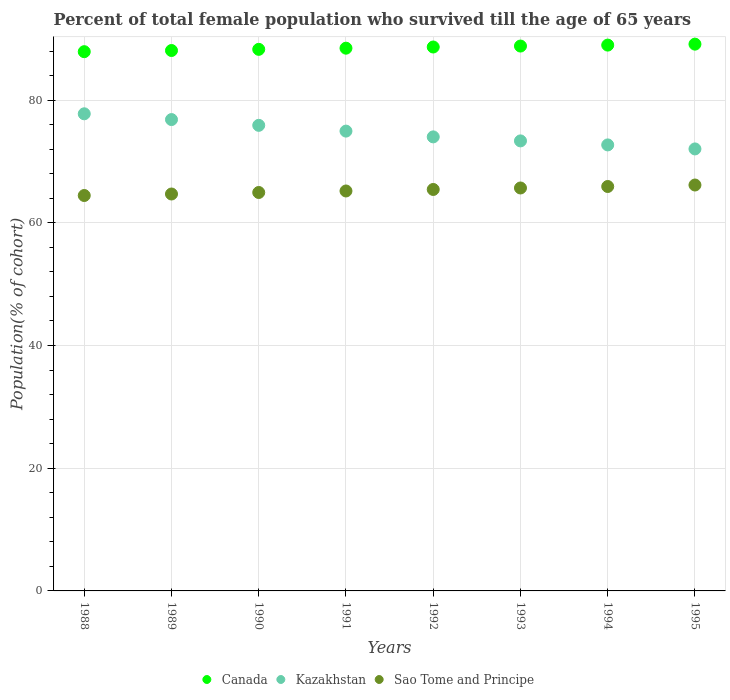How many different coloured dotlines are there?
Provide a short and direct response. 3. What is the percentage of total female population who survived till the age of 65 years in Kazakhstan in 1988?
Keep it short and to the point. 77.77. Across all years, what is the maximum percentage of total female population who survived till the age of 65 years in Sao Tome and Principe?
Offer a terse response. 66.17. Across all years, what is the minimum percentage of total female population who survived till the age of 65 years in Kazakhstan?
Ensure brevity in your answer.  72.05. In which year was the percentage of total female population who survived till the age of 65 years in Kazakhstan minimum?
Provide a short and direct response. 1995. What is the total percentage of total female population who survived till the age of 65 years in Sao Tome and Principe in the graph?
Make the answer very short. 522.51. What is the difference between the percentage of total female population who survived till the age of 65 years in Sao Tome and Principe in 1993 and that in 1995?
Ensure brevity in your answer.  -0.48. What is the difference between the percentage of total female population who survived till the age of 65 years in Canada in 1993 and the percentage of total female population who survived till the age of 65 years in Kazakhstan in 1991?
Make the answer very short. 13.86. What is the average percentage of total female population who survived till the age of 65 years in Canada per year?
Give a very brief answer. 88.54. In the year 1991, what is the difference between the percentage of total female population who survived till the age of 65 years in Kazakhstan and percentage of total female population who survived till the age of 65 years in Sao Tome and Principe?
Your response must be concise. 9.76. What is the ratio of the percentage of total female population who survived till the age of 65 years in Canada in 1992 to that in 1993?
Your response must be concise. 1. What is the difference between the highest and the second highest percentage of total female population who survived till the age of 65 years in Canada?
Give a very brief answer. 0.16. What is the difference between the highest and the lowest percentage of total female population who survived till the age of 65 years in Kazakhstan?
Ensure brevity in your answer.  5.73. Is it the case that in every year, the sum of the percentage of total female population who survived till the age of 65 years in Canada and percentage of total female population who survived till the age of 65 years in Sao Tome and Principe  is greater than the percentage of total female population who survived till the age of 65 years in Kazakhstan?
Provide a succinct answer. Yes. Does the percentage of total female population who survived till the age of 65 years in Sao Tome and Principe monotonically increase over the years?
Keep it short and to the point. Yes. How many dotlines are there?
Provide a short and direct response. 3. Are the values on the major ticks of Y-axis written in scientific E-notation?
Provide a short and direct response. No. Does the graph contain any zero values?
Offer a very short reply. No. How are the legend labels stacked?
Provide a succinct answer. Horizontal. What is the title of the graph?
Your answer should be very brief. Percent of total female population who survived till the age of 65 years. Does "Nigeria" appear as one of the legend labels in the graph?
Give a very brief answer. No. What is the label or title of the X-axis?
Offer a terse response. Years. What is the label or title of the Y-axis?
Provide a short and direct response. Population(% of cohort). What is the Population(% of cohort) of Canada in 1988?
Ensure brevity in your answer.  87.9. What is the Population(% of cohort) of Kazakhstan in 1988?
Your answer should be compact. 77.77. What is the Population(% of cohort) of Sao Tome and Principe in 1988?
Your answer should be compact. 64.45. What is the Population(% of cohort) in Canada in 1989?
Provide a short and direct response. 88.09. What is the Population(% of cohort) in Kazakhstan in 1989?
Your response must be concise. 76.83. What is the Population(% of cohort) of Sao Tome and Principe in 1989?
Keep it short and to the point. 64.7. What is the Population(% of cohort) of Canada in 1990?
Your answer should be very brief. 88.28. What is the Population(% of cohort) in Kazakhstan in 1990?
Offer a very short reply. 75.89. What is the Population(% of cohort) of Sao Tome and Principe in 1990?
Offer a very short reply. 64.95. What is the Population(% of cohort) in Canada in 1991?
Your answer should be compact. 88.47. What is the Population(% of cohort) of Kazakhstan in 1991?
Your answer should be compact. 74.95. What is the Population(% of cohort) of Sao Tome and Principe in 1991?
Offer a very short reply. 65.19. What is the Population(% of cohort) of Canada in 1992?
Make the answer very short. 88.66. What is the Population(% of cohort) in Kazakhstan in 1992?
Offer a very short reply. 74.01. What is the Population(% of cohort) in Sao Tome and Principe in 1992?
Your response must be concise. 65.44. What is the Population(% of cohort) in Canada in 1993?
Ensure brevity in your answer.  88.82. What is the Population(% of cohort) of Kazakhstan in 1993?
Ensure brevity in your answer.  73.36. What is the Population(% of cohort) of Sao Tome and Principe in 1993?
Provide a short and direct response. 65.68. What is the Population(% of cohort) of Canada in 1994?
Your answer should be very brief. 88.97. What is the Population(% of cohort) in Kazakhstan in 1994?
Provide a succinct answer. 72.7. What is the Population(% of cohort) of Sao Tome and Principe in 1994?
Ensure brevity in your answer.  65.92. What is the Population(% of cohort) of Canada in 1995?
Make the answer very short. 89.13. What is the Population(% of cohort) of Kazakhstan in 1995?
Provide a succinct answer. 72.05. What is the Population(% of cohort) in Sao Tome and Principe in 1995?
Ensure brevity in your answer.  66.17. Across all years, what is the maximum Population(% of cohort) of Canada?
Your response must be concise. 89.13. Across all years, what is the maximum Population(% of cohort) in Kazakhstan?
Offer a very short reply. 77.77. Across all years, what is the maximum Population(% of cohort) of Sao Tome and Principe?
Your answer should be very brief. 66.17. Across all years, what is the minimum Population(% of cohort) of Canada?
Offer a terse response. 87.9. Across all years, what is the minimum Population(% of cohort) of Kazakhstan?
Offer a terse response. 72.05. Across all years, what is the minimum Population(% of cohort) in Sao Tome and Principe?
Provide a succinct answer. 64.45. What is the total Population(% of cohort) in Canada in the graph?
Keep it short and to the point. 708.32. What is the total Population(% of cohort) of Kazakhstan in the graph?
Provide a short and direct response. 597.57. What is the total Population(% of cohort) in Sao Tome and Principe in the graph?
Give a very brief answer. 522.51. What is the difference between the Population(% of cohort) in Canada in 1988 and that in 1989?
Provide a short and direct response. -0.19. What is the difference between the Population(% of cohort) in Kazakhstan in 1988 and that in 1989?
Your answer should be compact. 0.94. What is the difference between the Population(% of cohort) of Sao Tome and Principe in 1988 and that in 1989?
Offer a terse response. -0.25. What is the difference between the Population(% of cohort) of Canada in 1988 and that in 1990?
Ensure brevity in your answer.  -0.38. What is the difference between the Population(% of cohort) of Kazakhstan in 1988 and that in 1990?
Provide a short and direct response. 1.88. What is the difference between the Population(% of cohort) of Sao Tome and Principe in 1988 and that in 1990?
Ensure brevity in your answer.  -0.49. What is the difference between the Population(% of cohort) in Canada in 1988 and that in 1991?
Offer a terse response. -0.57. What is the difference between the Population(% of cohort) in Kazakhstan in 1988 and that in 1991?
Give a very brief answer. 2.82. What is the difference between the Population(% of cohort) of Sao Tome and Principe in 1988 and that in 1991?
Offer a very short reply. -0.74. What is the difference between the Population(% of cohort) in Canada in 1988 and that in 1992?
Ensure brevity in your answer.  -0.76. What is the difference between the Population(% of cohort) of Kazakhstan in 1988 and that in 1992?
Give a very brief answer. 3.76. What is the difference between the Population(% of cohort) in Sao Tome and Principe in 1988 and that in 1992?
Offer a terse response. -0.99. What is the difference between the Population(% of cohort) of Canada in 1988 and that in 1993?
Ensure brevity in your answer.  -0.92. What is the difference between the Population(% of cohort) in Kazakhstan in 1988 and that in 1993?
Provide a succinct answer. 4.42. What is the difference between the Population(% of cohort) in Sao Tome and Principe in 1988 and that in 1993?
Your answer should be compact. -1.23. What is the difference between the Population(% of cohort) of Canada in 1988 and that in 1994?
Offer a terse response. -1.07. What is the difference between the Population(% of cohort) of Kazakhstan in 1988 and that in 1994?
Offer a terse response. 5.07. What is the difference between the Population(% of cohort) of Sao Tome and Principe in 1988 and that in 1994?
Give a very brief answer. -1.47. What is the difference between the Population(% of cohort) in Canada in 1988 and that in 1995?
Offer a very short reply. -1.23. What is the difference between the Population(% of cohort) in Kazakhstan in 1988 and that in 1995?
Ensure brevity in your answer.  5.73. What is the difference between the Population(% of cohort) in Sao Tome and Principe in 1988 and that in 1995?
Provide a succinct answer. -1.71. What is the difference between the Population(% of cohort) of Canada in 1989 and that in 1990?
Provide a short and direct response. -0.19. What is the difference between the Population(% of cohort) in Kazakhstan in 1989 and that in 1990?
Offer a very short reply. 0.94. What is the difference between the Population(% of cohort) in Sao Tome and Principe in 1989 and that in 1990?
Provide a succinct answer. -0.25. What is the difference between the Population(% of cohort) in Canada in 1989 and that in 1991?
Offer a very short reply. -0.38. What is the difference between the Population(% of cohort) of Kazakhstan in 1989 and that in 1991?
Give a very brief answer. 1.88. What is the difference between the Population(% of cohort) in Sao Tome and Principe in 1989 and that in 1991?
Provide a succinct answer. -0.49. What is the difference between the Population(% of cohort) in Canada in 1989 and that in 1992?
Give a very brief answer. -0.57. What is the difference between the Population(% of cohort) of Kazakhstan in 1989 and that in 1992?
Provide a short and direct response. 2.82. What is the difference between the Population(% of cohort) in Sao Tome and Principe in 1989 and that in 1992?
Provide a succinct answer. -0.74. What is the difference between the Population(% of cohort) of Canada in 1989 and that in 1993?
Your answer should be compact. -0.73. What is the difference between the Population(% of cohort) in Kazakhstan in 1989 and that in 1993?
Provide a short and direct response. 3.48. What is the difference between the Population(% of cohort) of Sao Tome and Principe in 1989 and that in 1993?
Your answer should be compact. -0.98. What is the difference between the Population(% of cohort) in Canada in 1989 and that in 1994?
Make the answer very short. -0.88. What is the difference between the Population(% of cohort) of Kazakhstan in 1989 and that in 1994?
Keep it short and to the point. 4.13. What is the difference between the Population(% of cohort) of Sao Tome and Principe in 1989 and that in 1994?
Offer a terse response. -1.22. What is the difference between the Population(% of cohort) in Canada in 1989 and that in 1995?
Provide a short and direct response. -1.04. What is the difference between the Population(% of cohort) of Kazakhstan in 1989 and that in 1995?
Give a very brief answer. 4.79. What is the difference between the Population(% of cohort) in Sao Tome and Principe in 1989 and that in 1995?
Provide a short and direct response. -1.46. What is the difference between the Population(% of cohort) in Canada in 1990 and that in 1991?
Offer a very short reply. -0.19. What is the difference between the Population(% of cohort) in Kazakhstan in 1990 and that in 1991?
Your answer should be very brief. 0.94. What is the difference between the Population(% of cohort) in Sao Tome and Principe in 1990 and that in 1991?
Provide a short and direct response. -0.25. What is the difference between the Population(% of cohort) in Canada in 1990 and that in 1992?
Offer a very short reply. -0.38. What is the difference between the Population(% of cohort) of Kazakhstan in 1990 and that in 1992?
Offer a very short reply. 1.88. What is the difference between the Population(% of cohort) of Sao Tome and Principe in 1990 and that in 1992?
Your answer should be very brief. -0.49. What is the difference between the Population(% of cohort) in Canada in 1990 and that in 1993?
Your answer should be very brief. -0.54. What is the difference between the Population(% of cohort) in Kazakhstan in 1990 and that in 1993?
Keep it short and to the point. 2.54. What is the difference between the Population(% of cohort) of Sao Tome and Principe in 1990 and that in 1993?
Ensure brevity in your answer.  -0.73. What is the difference between the Population(% of cohort) in Canada in 1990 and that in 1994?
Keep it short and to the point. -0.69. What is the difference between the Population(% of cohort) in Kazakhstan in 1990 and that in 1994?
Ensure brevity in your answer.  3.19. What is the difference between the Population(% of cohort) in Sao Tome and Principe in 1990 and that in 1994?
Keep it short and to the point. -0.98. What is the difference between the Population(% of cohort) of Canada in 1990 and that in 1995?
Offer a terse response. -0.85. What is the difference between the Population(% of cohort) in Kazakhstan in 1990 and that in 1995?
Ensure brevity in your answer.  3.84. What is the difference between the Population(% of cohort) of Sao Tome and Principe in 1990 and that in 1995?
Offer a very short reply. -1.22. What is the difference between the Population(% of cohort) of Canada in 1991 and that in 1992?
Offer a terse response. -0.19. What is the difference between the Population(% of cohort) of Kazakhstan in 1991 and that in 1992?
Make the answer very short. 0.94. What is the difference between the Population(% of cohort) in Sao Tome and Principe in 1991 and that in 1992?
Your response must be concise. -0.25. What is the difference between the Population(% of cohort) in Canada in 1991 and that in 1993?
Your answer should be very brief. -0.35. What is the difference between the Population(% of cohort) of Kazakhstan in 1991 and that in 1993?
Provide a short and direct response. 1.6. What is the difference between the Population(% of cohort) of Sao Tome and Principe in 1991 and that in 1993?
Keep it short and to the point. -0.49. What is the difference between the Population(% of cohort) in Canada in 1991 and that in 1994?
Provide a short and direct response. -0.5. What is the difference between the Population(% of cohort) of Kazakhstan in 1991 and that in 1994?
Keep it short and to the point. 2.25. What is the difference between the Population(% of cohort) of Sao Tome and Principe in 1991 and that in 1994?
Keep it short and to the point. -0.73. What is the difference between the Population(% of cohort) of Canada in 1991 and that in 1995?
Your answer should be very brief. -0.66. What is the difference between the Population(% of cohort) in Kazakhstan in 1991 and that in 1995?
Keep it short and to the point. 2.9. What is the difference between the Population(% of cohort) of Sao Tome and Principe in 1991 and that in 1995?
Make the answer very short. -0.97. What is the difference between the Population(% of cohort) in Canada in 1992 and that in 1993?
Your response must be concise. -0.16. What is the difference between the Population(% of cohort) of Kazakhstan in 1992 and that in 1993?
Make the answer very short. 0.65. What is the difference between the Population(% of cohort) of Sao Tome and Principe in 1992 and that in 1993?
Offer a very short reply. -0.24. What is the difference between the Population(% of cohort) in Canada in 1992 and that in 1994?
Provide a succinct answer. -0.31. What is the difference between the Population(% of cohort) of Kazakhstan in 1992 and that in 1994?
Ensure brevity in your answer.  1.31. What is the difference between the Population(% of cohort) in Sao Tome and Principe in 1992 and that in 1994?
Give a very brief answer. -0.48. What is the difference between the Population(% of cohort) in Canada in 1992 and that in 1995?
Keep it short and to the point. -0.47. What is the difference between the Population(% of cohort) of Kazakhstan in 1992 and that in 1995?
Your answer should be very brief. 1.96. What is the difference between the Population(% of cohort) of Sao Tome and Principe in 1992 and that in 1995?
Your answer should be very brief. -0.73. What is the difference between the Population(% of cohort) of Canada in 1993 and that in 1994?
Offer a terse response. -0.16. What is the difference between the Population(% of cohort) of Kazakhstan in 1993 and that in 1994?
Make the answer very short. 0.65. What is the difference between the Population(% of cohort) of Sao Tome and Principe in 1993 and that in 1994?
Offer a very short reply. -0.24. What is the difference between the Population(% of cohort) in Canada in 1993 and that in 1995?
Your answer should be compact. -0.31. What is the difference between the Population(% of cohort) of Kazakhstan in 1993 and that in 1995?
Offer a terse response. 1.31. What is the difference between the Population(% of cohort) of Sao Tome and Principe in 1993 and that in 1995?
Your response must be concise. -0.48. What is the difference between the Population(% of cohort) in Canada in 1994 and that in 1995?
Ensure brevity in your answer.  -0.16. What is the difference between the Population(% of cohort) of Kazakhstan in 1994 and that in 1995?
Your answer should be compact. 0.65. What is the difference between the Population(% of cohort) of Sao Tome and Principe in 1994 and that in 1995?
Your response must be concise. -0.24. What is the difference between the Population(% of cohort) of Canada in 1988 and the Population(% of cohort) of Kazakhstan in 1989?
Ensure brevity in your answer.  11.07. What is the difference between the Population(% of cohort) of Canada in 1988 and the Population(% of cohort) of Sao Tome and Principe in 1989?
Your answer should be very brief. 23.2. What is the difference between the Population(% of cohort) of Kazakhstan in 1988 and the Population(% of cohort) of Sao Tome and Principe in 1989?
Offer a terse response. 13.07. What is the difference between the Population(% of cohort) of Canada in 1988 and the Population(% of cohort) of Kazakhstan in 1990?
Keep it short and to the point. 12.01. What is the difference between the Population(% of cohort) of Canada in 1988 and the Population(% of cohort) of Sao Tome and Principe in 1990?
Give a very brief answer. 22.95. What is the difference between the Population(% of cohort) of Kazakhstan in 1988 and the Population(% of cohort) of Sao Tome and Principe in 1990?
Offer a very short reply. 12.83. What is the difference between the Population(% of cohort) of Canada in 1988 and the Population(% of cohort) of Kazakhstan in 1991?
Ensure brevity in your answer.  12.95. What is the difference between the Population(% of cohort) in Canada in 1988 and the Population(% of cohort) in Sao Tome and Principe in 1991?
Ensure brevity in your answer.  22.71. What is the difference between the Population(% of cohort) in Kazakhstan in 1988 and the Population(% of cohort) in Sao Tome and Principe in 1991?
Provide a short and direct response. 12.58. What is the difference between the Population(% of cohort) of Canada in 1988 and the Population(% of cohort) of Kazakhstan in 1992?
Ensure brevity in your answer.  13.89. What is the difference between the Population(% of cohort) of Canada in 1988 and the Population(% of cohort) of Sao Tome and Principe in 1992?
Offer a very short reply. 22.46. What is the difference between the Population(% of cohort) in Kazakhstan in 1988 and the Population(% of cohort) in Sao Tome and Principe in 1992?
Offer a terse response. 12.33. What is the difference between the Population(% of cohort) in Canada in 1988 and the Population(% of cohort) in Kazakhstan in 1993?
Make the answer very short. 14.54. What is the difference between the Population(% of cohort) of Canada in 1988 and the Population(% of cohort) of Sao Tome and Principe in 1993?
Provide a short and direct response. 22.22. What is the difference between the Population(% of cohort) in Kazakhstan in 1988 and the Population(% of cohort) in Sao Tome and Principe in 1993?
Provide a succinct answer. 12.09. What is the difference between the Population(% of cohort) of Canada in 1988 and the Population(% of cohort) of Kazakhstan in 1994?
Your answer should be very brief. 15.2. What is the difference between the Population(% of cohort) in Canada in 1988 and the Population(% of cohort) in Sao Tome and Principe in 1994?
Keep it short and to the point. 21.98. What is the difference between the Population(% of cohort) in Kazakhstan in 1988 and the Population(% of cohort) in Sao Tome and Principe in 1994?
Ensure brevity in your answer.  11.85. What is the difference between the Population(% of cohort) of Canada in 1988 and the Population(% of cohort) of Kazakhstan in 1995?
Ensure brevity in your answer.  15.85. What is the difference between the Population(% of cohort) in Canada in 1988 and the Population(% of cohort) in Sao Tome and Principe in 1995?
Provide a succinct answer. 21.73. What is the difference between the Population(% of cohort) of Kazakhstan in 1988 and the Population(% of cohort) of Sao Tome and Principe in 1995?
Provide a short and direct response. 11.61. What is the difference between the Population(% of cohort) of Canada in 1989 and the Population(% of cohort) of Kazakhstan in 1990?
Keep it short and to the point. 12.2. What is the difference between the Population(% of cohort) of Canada in 1989 and the Population(% of cohort) of Sao Tome and Principe in 1990?
Make the answer very short. 23.14. What is the difference between the Population(% of cohort) of Kazakhstan in 1989 and the Population(% of cohort) of Sao Tome and Principe in 1990?
Ensure brevity in your answer.  11.89. What is the difference between the Population(% of cohort) in Canada in 1989 and the Population(% of cohort) in Kazakhstan in 1991?
Ensure brevity in your answer.  13.14. What is the difference between the Population(% of cohort) in Canada in 1989 and the Population(% of cohort) in Sao Tome and Principe in 1991?
Offer a very short reply. 22.9. What is the difference between the Population(% of cohort) in Kazakhstan in 1989 and the Population(% of cohort) in Sao Tome and Principe in 1991?
Your answer should be compact. 11.64. What is the difference between the Population(% of cohort) of Canada in 1989 and the Population(% of cohort) of Kazakhstan in 1992?
Provide a succinct answer. 14.08. What is the difference between the Population(% of cohort) of Canada in 1989 and the Population(% of cohort) of Sao Tome and Principe in 1992?
Keep it short and to the point. 22.65. What is the difference between the Population(% of cohort) in Kazakhstan in 1989 and the Population(% of cohort) in Sao Tome and Principe in 1992?
Your answer should be very brief. 11.39. What is the difference between the Population(% of cohort) in Canada in 1989 and the Population(% of cohort) in Kazakhstan in 1993?
Provide a short and direct response. 14.73. What is the difference between the Population(% of cohort) in Canada in 1989 and the Population(% of cohort) in Sao Tome and Principe in 1993?
Keep it short and to the point. 22.41. What is the difference between the Population(% of cohort) of Kazakhstan in 1989 and the Population(% of cohort) of Sao Tome and Principe in 1993?
Offer a very short reply. 11.15. What is the difference between the Population(% of cohort) of Canada in 1989 and the Population(% of cohort) of Kazakhstan in 1994?
Your answer should be compact. 15.39. What is the difference between the Population(% of cohort) in Canada in 1989 and the Population(% of cohort) in Sao Tome and Principe in 1994?
Offer a very short reply. 22.17. What is the difference between the Population(% of cohort) in Kazakhstan in 1989 and the Population(% of cohort) in Sao Tome and Principe in 1994?
Offer a very short reply. 10.91. What is the difference between the Population(% of cohort) in Canada in 1989 and the Population(% of cohort) in Kazakhstan in 1995?
Offer a terse response. 16.04. What is the difference between the Population(% of cohort) in Canada in 1989 and the Population(% of cohort) in Sao Tome and Principe in 1995?
Provide a short and direct response. 21.92. What is the difference between the Population(% of cohort) in Kazakhstan in 1989 and the Population(% of cohort) in Sao Tome and Principe in 1995?
Your answer should be compact. 10.67. What is the difference between the Population(% of cohort) in Canada in 1990 and the Population(% of cohort) in Kazakhstan in 1991?
Offer a very short reply. 13.33. What is the difference between the Population(% of cohort) of Canada in 1990 and the Population(% of cohort) of Sao Tome and Principe in 1991?
Keep it short and to the point. 23.09. What is the difference between the Population(% of cohort) of Kazakhstan in 1990 and the Population(% of cohort) of Sao Tome and Principe in 1991?
Your answer should be compact. 10.7. What is the difference between the Population(% of cohort) in Canada in 1990 and the Population(% of cohort) in Kazakhstan in 1992?
Provide a succinct answer. 14.27. What is the difference between the Population(% of cohort) in Canada in 1990 and the Population(% of cohort) in Sao Tome and Principe in 1992?
Keep it short and to the point. 22.84. What is the difference between the Population(% of cohort) in Kazakhstan in 1990 and the Population(% of cohort) in Sao Tome and Principe in 1992?
Keep it short and to the point. 10.45. What is the difference between the Population(% of cohort) of Canada in 1990 and the Population(% of cohort) of Kazakhstan in 1993?
Make the answer very short. 14.92. What is the difference between the Population(% of cohort) in Canada in 1990 and the Population(% of cohort) in Sao Tome and Principe in 1993?
Provide a succinct answer. 22.6. What is the difference between the Population(% of cohort) in Kazakhstan in 1990 and the Population(% of cohort) in Sao Tome and Principe in 1993?
Offer a terse response. 10.21. What is the difference between the Population(% of cohort) of Canada in 1990 and the Population(% of cohort) of Kazakhstan in 1994?
Provide a short and direct response. 15.58. What is the difference between the Population(% of cohort) of Canada in 1990 and the Population(% of cohort) of Sao Tome and Principe in 1994?
Provide a succinct answer. 22.36. What is the difference between the Population(% of cohort) of Kazakhstan in 1990 and the Population(% of cohort) of Sao Tome and Principe in 1994?
Give a very brief answer. 9.97. What is the difference between the Population(% of cohort) in Canada in 1990 and the Population(% of cohort) in Kazakhstan in 1995?
Give a very brief answer. 16.23. What is the difference between the Population(% of cohort) in Canada in 1990 and the Population(% of cohort) in Sao Tome and Principe in 1995?
Give a very brief answer. 22.11. What is the difference between the Population(% of cohort) in Kazakhstan in 1990 and the Population(% of cohort) in Sao Tome and Principe in 1995?
Provide a succinct answer. 9.73. What is the difference between the Population(% of cohort) of Canada in 1991 and the Population(% of cohort) of Kazakhstan in 1992?
Offer a terse response. 14.46. What is the difference between the Population(% of cohort) in Canada in 1991 and the Population(% of cohort) in Sao Tome and Principe in 1992?
Your answer should be compact. 23.03. What is the difference between the Population(% of cohort) in Kazakhstan in 1991 and the Population(% of cohort) in Sao Tome and Principe in 1992?
Give a very brief answer. 9.51. What is the difference between the Population(% of cohort) of Canada in 1991 and the Population(% of cohort) of Kazakhstan in 1993?
Provide a short and direct response. 15.11. What is the difference between the Population(% of cohort) of Canada in 1991 and the Population(% of cohort) of Sao Tome and Principe in 1993?
Offer a terse response. 22.79. What is the difference between the Population(% of cohort) in Kazakhstan in 1991 and the Population(% of cohort) in Sao Tome and Principe in 1993?
Your answer should be very brief. 9.27. What is the difference between the Population(% of cohort) of Canada in 1991 and the Population(% of cohort) of Kazakhstan in 1994?
Provide a short and direct response. 15.77. What is the difference between the Population(% of cohort) in Canada in 1991 and the Population(% of cohort) in Sao Tome and Principe in 1994?
Provide a short and direct response. 22.55. What is the difference between the Population(% of cohort) of Kazakhstan in 1991 and the Population(% of cohort) of Sao Tome and Principe in 1994?
Ensure brevity in your answer.  9.03. What is the difference between the Population(% of cohort) of Canada in 1991 and the Population(% of cohort) of Kazakhstan in 1995?
Offer a very short reply. 16.42. What is the difference between the Population(% of cohort) in Canada in 1991 and the Population(% of cohort) in Sao Tome and Principe in 1995?
Make the answer very short. 22.31. What is the difference between the Population(% of cohort) in Kazakhstan in 1991 and the Population(% of cohort) in Sao Tome and Principe in 1995?
Provide a short and direct response. 8.79. What is the difference between the Population(% of cohort) of Canada in 1992 and the Population(% of cohort) of Kazakhstan in 1993?
Your response must be concise. 15.3. What is the difference between the Population(% of cohort) of Canada in 1992 and the Population(% of cohort) of Sao Tome and Principe in 1993?
Provide a succinct answer. 22.98. What is the difference between the Population(% of cohort) in Kazakhstan in 1992 and the Population(% of cohort) in Sao Tome and Principe in 1993?
Offer a terse response. 8.33. What is the difference between the Population(% of cohort) of Canada in 1992 and the Population(% of cohort) of Kazakhstan in 1994?
Your response must be concise. 15.96. What is the difference between the Population(% of cohort) of Canada in 1992 and the Population(% of cohort) of Sao Tome and Principe in 1994?
Give a very brief answer. 22.74. What is the difference between the Population(% of cohort) in Kazakhstan in 1992 and the Population(% of cohort) in Sao Tome and Principe in 1994?
Make the answer very short. 8.09. What is the difference between the Population(% of cohort) in Canada in 1992 and the Population(% of cohort) in Kazakhstan in 1995?
Your response must be concise. 16.61. What is the difference between the Population(% of cohort) in Canada in 1992 and the Population(% of cohort) in Sao Tome and Principe in 1995?
Your answer should be compact. 22.5. What is the difference between the Population(% of cohort) in Kazakhstan in 1992 and the Population(% of cohort) in Sao Tome and Principe in 1995?
Provide a short and direct response. 7.85. What is the difference between the Population(% of cohort) of Canada in 1993 and the Population(% of cohort) of Kazakhstan in 1994?
Give a very brief answer. 16.11. What is the difference between the Population(% of cohort) in Canada in 1993 and the Population(% of cohort) in Sao Tome and Principe in 1994?
Make the answer very short. 22.89. What is the difference between the Population(% of cohort) in Kazakhstan in 1993 and the Population(% of cohort) in Sao Tome and Principe in 1994?
Your answer should be compact. 7.43. What is the difference between the Population(% of cohort) of Canada in 1993 and the Population(% of cohort) of Kazakhstan in 1995?
Keep it short and to the point. 16.77. What is the difference between the Population(% of cohort) of Canada in 1993 and the Population(% of cohort) of Sao Tome and Principe in 1995?
Offer a terse response. 22.65. What is the difference between the Population(% of cohort) in Kazakhstan in 1993 and the Population(% of cohort) in Sao Tome and Principe in 1995?
Your response must be concise. 7.19. What is the difference between the Population(% of cohort) in Canada in 1994 and the Population(% of cohort) in Kazakhstan in 1995?
Ensure brevity in your answer.  16.92. What is the difference between the Population(% of cohort) in Canada in 1994 and the Population(% of cohort) in Sao Tome and Principe in 1995?
Your answer should be compact. 22.81. What is the difference between the Population(% of cohort) of Kazakhstan in 1994 and the Population(% of cohort) of Sao Tome and Principe in 1995?
Ensure brevity in your answer.  6.54. What is the average Population(% of cohort) of Canada per year?
Keep it short and to the point. 88.54. What is the average Population(% of cohort) in Kazakhstan per year?
Your answer should be compact. 74.7. What is the average Population(% of cohort) of Sao Tome and Principe per year?
Make the answer very short. 65.31. In the year 1988, what is the difference between the Population(% of cohort) of Canada and Population(% of cohort) of Kazakhstan?
Give a very brief answer. 10.13. In the year 1988, what is the difference between the Population(% of cohort) of Canada and Population(% of cohort) of Sao Tome and Principe?
Your response must be concise. 23.45. In the year 1988, what is the difference between the Population(% of cohort) in Kazakhstan and Population(% of cohort) in Sao Tome and Principe?
Make the answer very short. 13.32. In the year 1989, what is the difference between the Population(% of cohort) in Canada and Population(% of cohort) in Kazakhstan?
Offer a terse response. 11.26. In the year 1989, what is the difference between the Population(% of cohort) in Canada and Population(% of cohort) in Sao Tome and Principe?
Ensure brevity in your answer.  23.39. In the year 1989, what is the difference between the Population(% of cohort) of Kazakhstan and Population(% of cohort) of Sao Tome and Principe?
Provide a short and direct response. 12.13. In the year 1990, what is the difference between the Population(% of cohort) of Canada and Population(% of cohort) of Kazakhstan?
Your answer should be very brief. 12.39. In the year 1990, what is the difference between the Population(% of cohort) of Canada and Population(% of cohort) of Sao Tome and Principe?
Provide a succinct answer. 23.33. In the year 1990, what is the difference between the Population(% of cohort) in Kazakhstan and Population(% of cohort) in Sao Tome and Principe?
Your answer should be very brief. 10.95. In the year 1991, what is the difference between the Population(% of cohort) in Canada and Population(% of cohort) in Kazakhstan?
Your answer should be very brief. 13.52. In the year 1991, what is the difference between the Population(% of cohort) in Canada and Population(% of cohort) in Sao Tome and Principe?
Ensure brevity in your answer.  23.28. In the year 1991, what is the difference between the Population(% of cohort) of Kazakhstan and Population(% of cohort) of Sao Tome and Principe?
Make the answer very short. 9.76. In the year 1992, what is the difference between the Population(% of cohort) in Canada and Population(% of cohort) in Kazakhstan?
Offer a very short reply. 14.65. In the year 1992, what is the difference between the Population(% of cohort) of Canada and Population(% of cohort) of Sao Tome and Principe?
Your answer should be compact. 23.22. In the year 1992, what is the difference between the Population(% of cohort) in Kazakhstan and Population(% of cohort) in Sao Tome and Principe?
Your answer should be compact. 8.57. In the year 1993, what is the difference between the Population(% of cohort) of Canada and Population(% of cohort) of Kazakhstan?
Give a very brief answer. 15.46. In the year 1993, what is the difference between the Population(% of cohort) of Canada and Population(% of cohort) of Sao Tome and Principe?
Your answer should be very brief. 23.14. In the year 1993, what is the difference between the Population(% of cohort) of Kazakhstan and Population(% of cohort) of Sao Tome and Principe?
Keep it short and to the point. 7.68. In the year 1994, what is the difference between the Population(% of cohort) in Canada and Population(% of cohort) in Kazakhstan?
Provide a short and direct response. 16.27. In the year 1994, what is the difference between the Population(% of cohort) of Canada and Population(% of cohort) of Sao Tome and Principe?
Give a very brief answer. 23.05. In the year 1994, what is the difference between the Population(% of cohort) in Kazakhstan and Population(% of cohort) in Sao Tome and Principe?
Provide a succinct answer. 6.78. In the year 1995, what is the difference between the Population(% of cohort) in Canada and Population(% of cohort) in Kazakhstan?
Make the answer very short. 17.08. In the year 1995, what is the difference between the Population(% of cohort) of Canada and Population(% of cohort) of Sao Tome and Principe?
Offer a very short reply. 22.96. In the year 1995, what is the difference between the Population(% of cohort) in Kazakhstan and Population(% of cohort) in Sao Tome and Principe?
Your answer should be very brief. 5.88. What is the ratio of the Population(% of cohort) in Canada in 1988 to that in 1989?
Make the answer very short. 1. What is the ratio of the Population(% of cohort) in Kazakhstan in 1988 to that in 1989?
Give a very brief answer. 1.01. What is the ratio of the Population(% of cohort) of Sao Tome and Principe in 1988 to that in 1989?
Provide a succinct answer. 1. What is the ratio of the Population(% of cohort) of Kazakhstan in 1988 to that in 1990?
Provide a succinct answer. 1.02. What is the ratio of the Population(% of cohort) in Canada in 1988 to that in 1991?
Offer a terse response. 0.99. What is the ratio of the Population(% of cohort) in Kazakhstan in 1988 to that in 1991?
Give a very brief answer. 1.04. What is the ratio of the Population(% of cohort) in Sao Tome and Principe in 1988 to that in 1991?
Give a very brief answer. 0.99. What is the ratio of the Population(% of cohort) in Kazakhstan in 1988 to that in 1992?
Your response must be concise. 1.05. What is the ratio of the Population(% of cohort) in Sao Tome and Principe in 1988 to that in 1992?
Provide a short and direct response. 0.98. What is the ratio of the Population(% of cohort) in Kazakhstan in 1988 to that in 1993?
Provide a succinct answer. 1.06. What is the ratio of the Population(% of cohort) of Sao Tome and Principe in 1988 to that in 1993?
Make the answer very short. 0.98. What is the ratio of the Population(% of cohort) in Canada in 1988 to that in 1994?
Keep it short and to the point. 0.99. What is the ratio of the Population(% of cohort) in Kazakhstan in 1988 to that in 1994?
Your answer should be compact. 1.07. What is the ratio of the Population(% of cohort) in Sao Tome and Principe in 1988 to that in 1994?
Offer a very short reply. 0.98. What is the ratio of the Population(% of cohort) in Canada in 1988 to that in 1995?
Offer a terse response. 0.99. What is the ratio of the Population(% of cohort) in Kazakhstan in 1988 to that in 1995?
Provide a short and direct response. 1.08. What is the ratio of the Population(% of cohort) of Sao Tome and Principe in 1988 to that in 1995?
Give a very brief answer. 0.97. What is the ratio of the Population(% of cohort) in Canada in 1989 to that in 1990?
Ensure brevity in your answer.  1. What is the ratio of the Population(% of cohort) of Kazakhstan in 1989 to that in 1990?
Your answer should be very brief. 1.01. What is the ratio of the Population(% of cohort) of Sao Tome and Principe in 1989 to that in 1990?
Your answer should be compact. 1. What is the ratio of the Population(% of cohort) of Kazakhstan in 1989 to that in 1991?
Your response must be concise. 1.03. What is the ratio of the Population(% of cohort) of Canada in 1989 to that in 1992?
Your answer should be very brief. 0.99. What is the ratio of the Population(% of cohort) in Kazakhstan in 1989 to that in 1992?
Your answer should be compact. 1.04. What is the ratio of the Population(% of cohort) in Sao Tome and Principe in 1989 to that in 1992?
Provide a short and direct response. 0.99. What is the ratio of the Population(% of cohort) in Canada in 1989 to that in 1993?
Give a very brief answer. 0.99. What is the ratio of the Population(% of cohort) in Kazakhstan in 1989 to that in 1993?
Keep it short and to the point. 1.05. What is the ratio of the Population(% of cohort) of Sao Tome and Principe in 1989 to that in 1993?
Give a very brief answer. 0.99. What is the ratio of the Population(% of cohort) of Kazakhstan in 1989 to that in 1994?
Offer a terse response. 1.06. What is the ratio of the Population(% of cohort) in Sao Tome and Principe in 1989 to that in 1994?
Make the answer very short. 0.98. What is the ratio of the Population(% of cohort) of Canada in 1989 to that in 1995?
Ensure brevity in your answer.  0.99. What is the ratio of the Population(% of cohort) of Kazakhstan in 1989 to that in 1995?
Keep it short and to the point. 1.07. What is the ratio of the Population(% of cohort) in Sao Tome and Principe in 1989 to that in 1995?
Offer a very short reply. 0.98. What is the ratio of the Population(% of cohort) of Canada in 1990 to that in 1991?
Give a very brief answer. 1. What is the ratio of the Population(% of cohort) in Kazakhstan in 1990 to that in 1991?
Offer a very short reply. 1.01. What is the ratio of the Population(% of cohort) in Kazakhstan in 1990 to that in 1992?
Make the answer very short. 1.03. What is the ratio of the Population(% of cohort) of Kazakhstan in 1990 to that in 1993?
Make the answer very short. 1.03. What is the ratio of the Population(% of cohort) of Kazakhstan in 1990 to that in 1994?
Ensure brevity in your answer.  1.04. What is the ratio of the Population(% of cohort) of Sao Tome and Principe in 1990 to that in 1994?
Keep it short and to the point. 0.99. What is the ratio of the Population(% of cohort) in Kazakhstan in 1990 to that in 1995?
Offer a very short reply. 1.05. What is the ratio of the Population(% of cohort) of Sao Tome and Principe in 1990 to that in 1995?
Ensure brevity in your answer.  0.98. What is the ratio of the Population(% of cohort) in Kazakhstan in 1991 to that in 1992?
Keep it short and to the point. 1.01. What is the ratio of the Population(% of cohort) in Sao Tome and Principe in 1991 to that in 1992?
Offer a very short reply. 1. What is the ratio of the Population(% of cohort) of Kazakhstan in 1991 to that in 1993?
Your answer should be very brief. 1.02. What is the ratio of the Population(% of cohort) of Kazakhstan in 1991 to that in 1994?
Offer a very short reply. 1.03. What is the ratio of the Population(% of cohort) of Sao Tome and Principe in 1991 to that in 1994?
Ensure brevity in your answer.  0.99. What is the ratio of the Population(% of cohort) in Kazakhstan in 1991 to that in 1995?
Your answer should be very brief. 1.04. What is the ratio of the Population(% of cohort) of Sao Tome and Principe in 1991 to that in 1995?
Ensure brevity in your answer.  0.99. What is the ratio of the Population(% of cohort) in Canada in 1992 to that in 1993?
Provide a succinct answer. 1. What is the ratio of the Population(% of cohort) in Kazakhstan in 1992 to that in 1993?
Your answer should be very brief. 1.01. What is the ratio of the Population(% of cohort) of Canada in 1992 to that in 1995?
Provide a short and direct response. 0.99. What is the ratio of the Population(% of cohort) of Kazakhstan in 1992 to that in 1995?
Your response must be concise. 1.03. What is the ratio of the Population(% of cohort) of Sao Tome and Principe in 1992 to that in 1995?
Your answer should be compact. 0.99. What is the ratio of the Population(% of cohort) of Canada in 1993 to that in 1994?
Your answer should be compact. 1. What is the ratio of the Population(% of cohort) in Sao Tome and Principe in 1993 to that in 1994?
Ensure brevity in your answer.  1. What is the ratio of the Population(% of cohort) of Canada in 1993 to that in 1995?
Your response must be concise. 1. What is the ratio of the Population(% of cohort) in Kazakhstan in 1993 to that in 1995?
Provide a succinct answer. 1.02. What is the ratio of the Population(% of cohort) in Sao Tome and Principe in 1993 to that in 1995?
Provide a succinct answer. 0.99. What is the ratio of the Population(% of cohort) of Canada in 1994 to that in 1995?
Provide a short and direct response. 1. What is the ratio of the Population(% of cohort) in Kazakhstan in 1994 to that in 1995?
Offer a very short reply. 1.01. What is the difference between the highest and the second highest Population(% of cohort) in Canada?
Give a very brief answer. 0.16. What is the difference between the highest and the second highest Population(% of cohort) of Kazakhstan?
Your answer should be very brief. 0.94. What is the difference between the highest and the second highest Population(% of cohort) of Sao Tome and Principe?
Provide a succinct answer. 0.24. What is the difference between the highest and the lowest Population(% of cohort) of Canada?
Your answer should be very brief. 1.23. What is the difference between the highest and the lowest Population(% of cohort) of Kazakhstan?
Your response must be concise. 5.73. What is the difference between the highest and the lowest Population(% of cohort) in Sao Tome and Principe?
Make the answer very short. 1.71. 